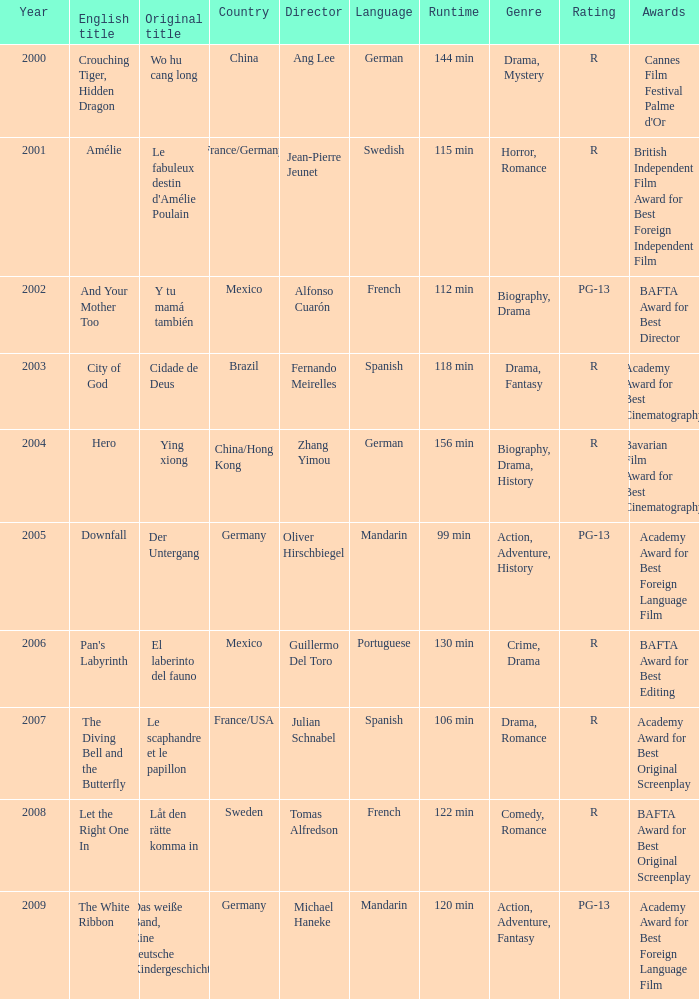Tell me the country for julian schnabel France/USA. 